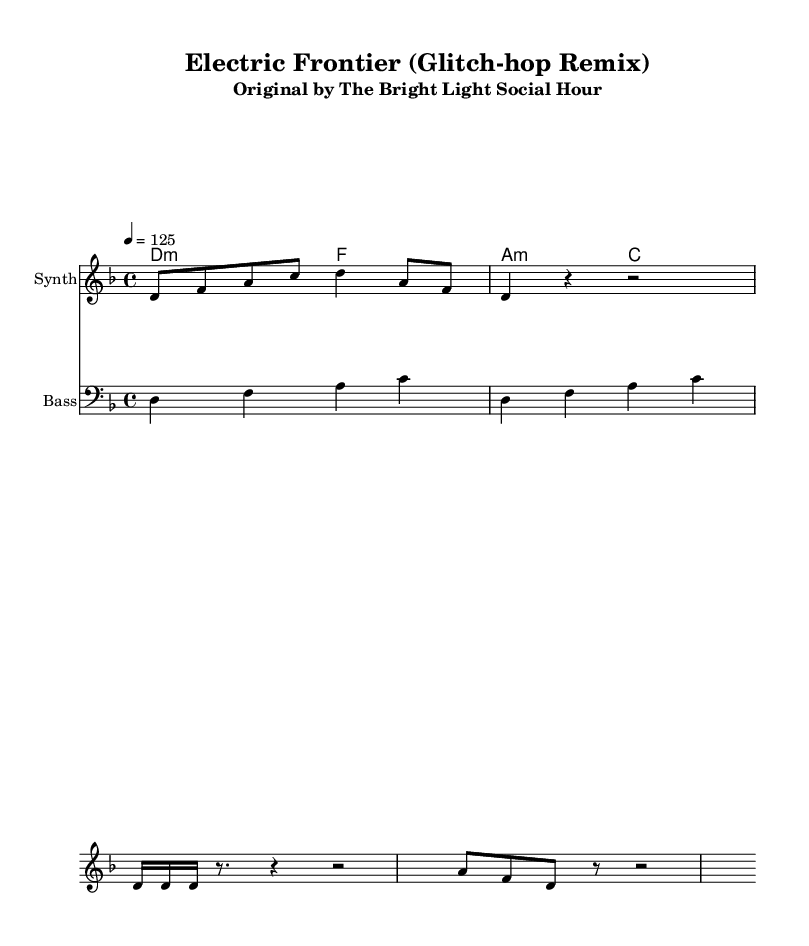What is the key signature of this music? The key signature indicated in the music is D minor, which has one flat (B flat). This is found at the beginning of the staff notation.
Answer: D minor What is the time signature of this music? The time signature shown in the score is 4/4, which means there are four beats in each measure and the quarter note receives one beat. This is typically noted at the beginning of the piece.
Answer: 4/4 What is the tempo marking for this piece? The tempo marking is given as 4 = 125, indicating that there are 125 beats per minute, which suggests a lively pace. This is indicated near the beginning of the score.
Answer: 125 What type of effects are used in the synthesizer part? The synthesizer part contains a glitch stutter effect and a reverse glitch effect, which are characteristic of glitch-hop music. This can be inferred from the specific rhythmic and note patterns indicated in the score.
Answer: Glitch stutter, reverse glitch How does the bass line relate to the chord progression? The bass line outlines the root notes of the chord progression provided above it, which are D minor, F minor, A minor, and C major. The bass notes emphasize the harmonic structure and reflect the given chords, supporting the overall sound.
Answer: Supports chord progression What is the primary instrument featured in the score? The primary instrument featured in the score is the synthesizer, as indicated in the instrument name at the start of the respective staff. This highlights its central role in the electronic piece.
Answer: Synthesizer What form of music does this piece represent? This piece represents glitch-hop, which is an electronic genre characterized by its use of "glitch" effects, often incorporating hip hop influences along with electronic sounds. The specific notations and techniques reflect this style.
Answer: Glitch-hop 